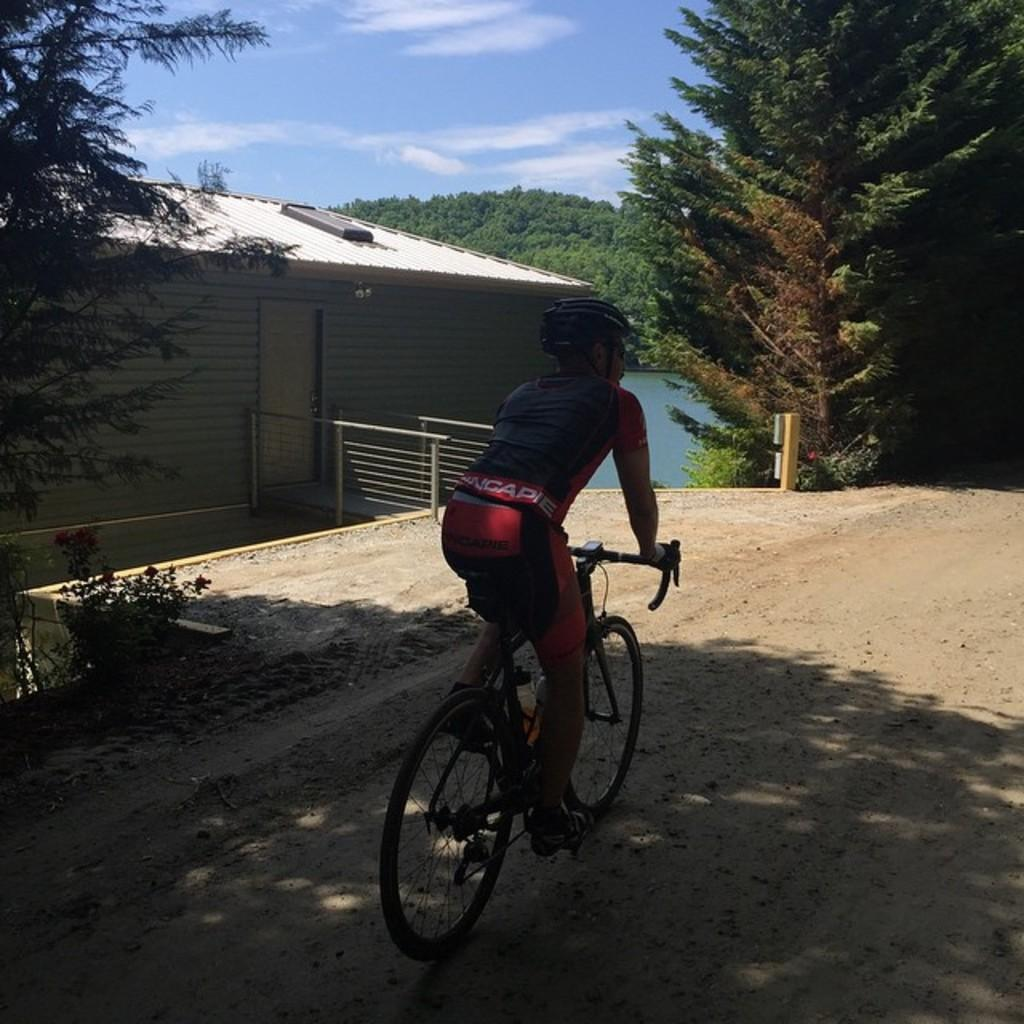What is the person in the image doing? The person is riding a bicycle in the image. What safety precaution is the person taking while riding the bicycle? The person is wearing a helmet. What type of structure can be seen in the image? There is a house in the image. What architectural feature is present in the image? There is a door and a railing in the image. What type of vegetation is visible in the image? There are trees in the image. What natural element is visible in the image? There is water visible in the image. What colors are used to depict the sky in the image? The sky is in white and blue color. What type of leg does the person's brother have in the image? There is no mention of a brother or any legs in the image; it only shows a person riding a bicycle. 